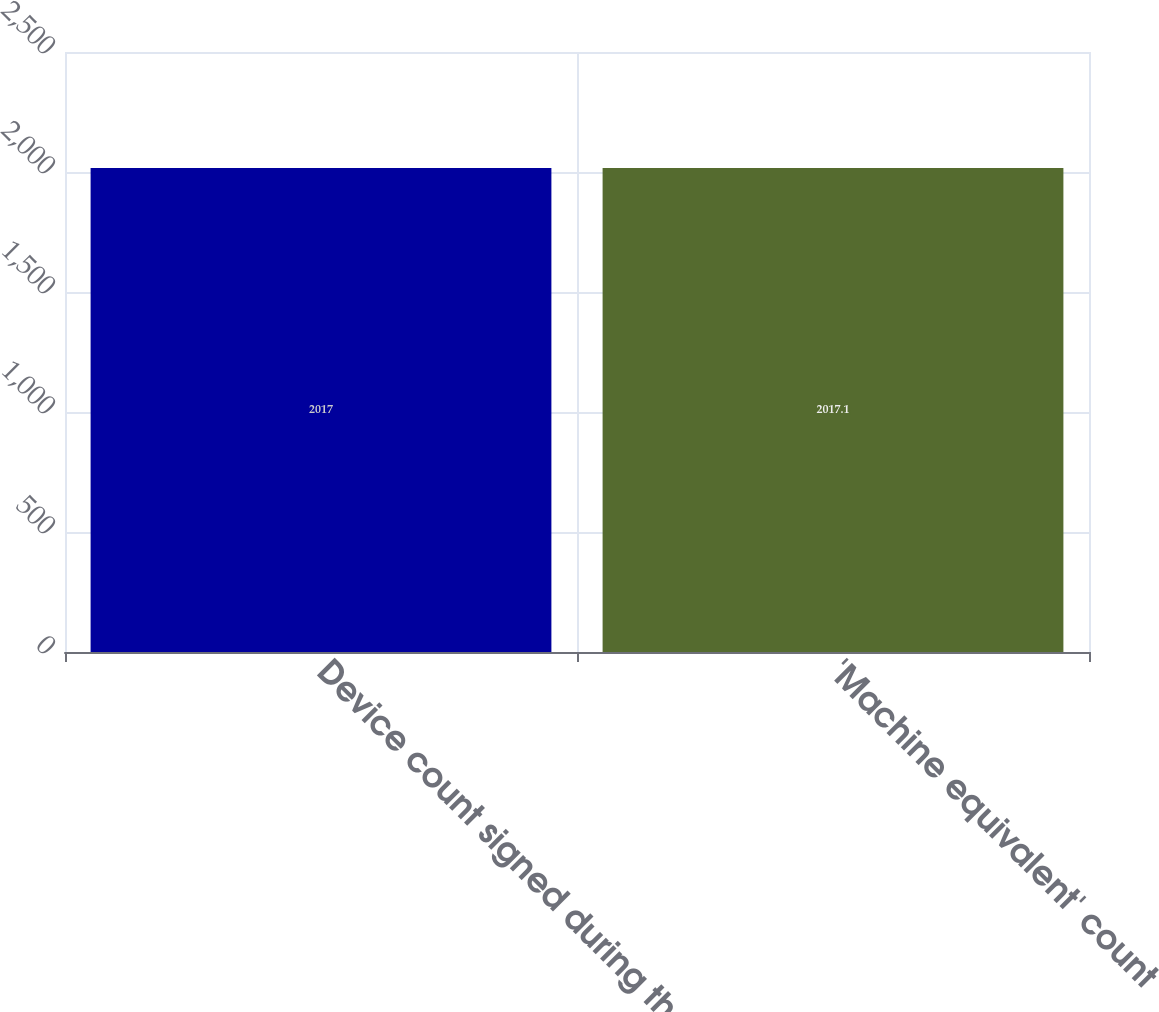Convert chart to OTSL. <chart><loc_0><loc_0><loc_500><loc_500><bar_chart><fcel>Device count signed during the<fcel>'Machine equivalent' count<nl><fcel>2017<fcel>2017.1<nl></chart> 